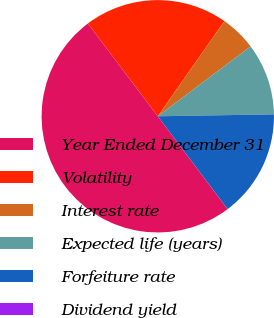<chart> <loc_0><loc_0><loc_500><loc_500><pie_chart><fcel>Year Ended December 31<fcel>Volatility<fcel>Interest rate<fcel>Expected life (years)<fcel>Forfeiture rate<fcel>Dividend yield<nl><fcel>49.97%<fcel>20.0%<fcel>5.01%<fcel>10.01%<fcel>15.0%<fcel>0.01%<nl></chart> 